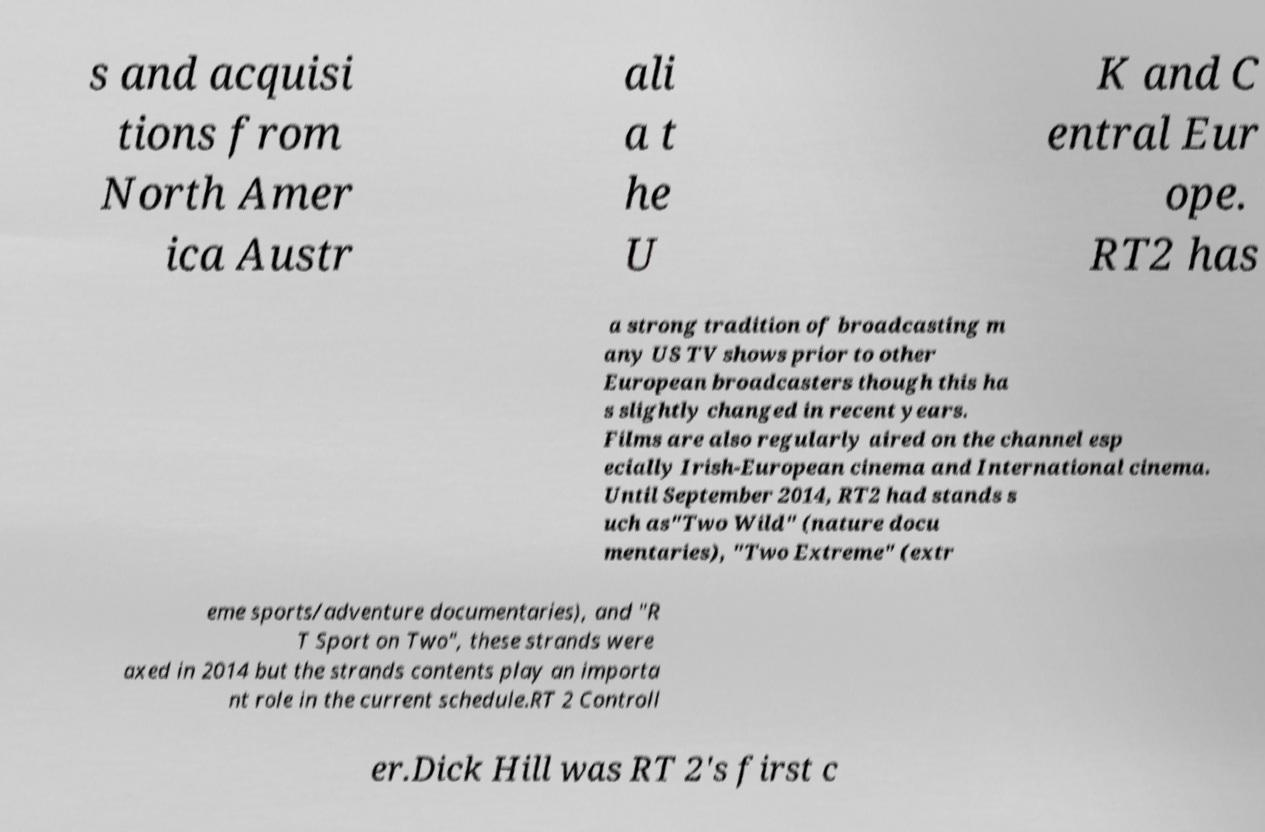Can you accurately transcribe the text from the provided image for me? s and acquisi tions from North Amer ica Austr ali a t he U K and C entral Eur ope. RT2 has a strong tradition of broadcasting m any US TV shows prior to other European broadcasters though this ha s slightly changed in recent years. Films are also regularly aired on the channel esp ecially Irish-European cinema and International cinema. Until September 2014, RT2 had stands s uch as"Two Wild" (nature docu mentaries), "Two Extreme" (extr eme sports/adventure documentaries), and "R T Sport on Two", these strands were axed in 2014 but the strands contents play an importa nt role in the current schedule.RT 2 Controll er.Dick Hill was RT 2's first c 